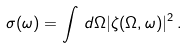Convert formula to latex. <formula><loc_0><loc_0><loc_500><loc_500>\sigma ( \omega ) = \int \, d \Omega | \zeta ( \Omega , \omega ) | ^ { 2 } \, .</formula> 